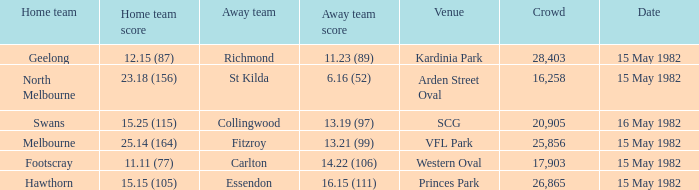What did the away team score when playing Footscray? 14.22 (106). 